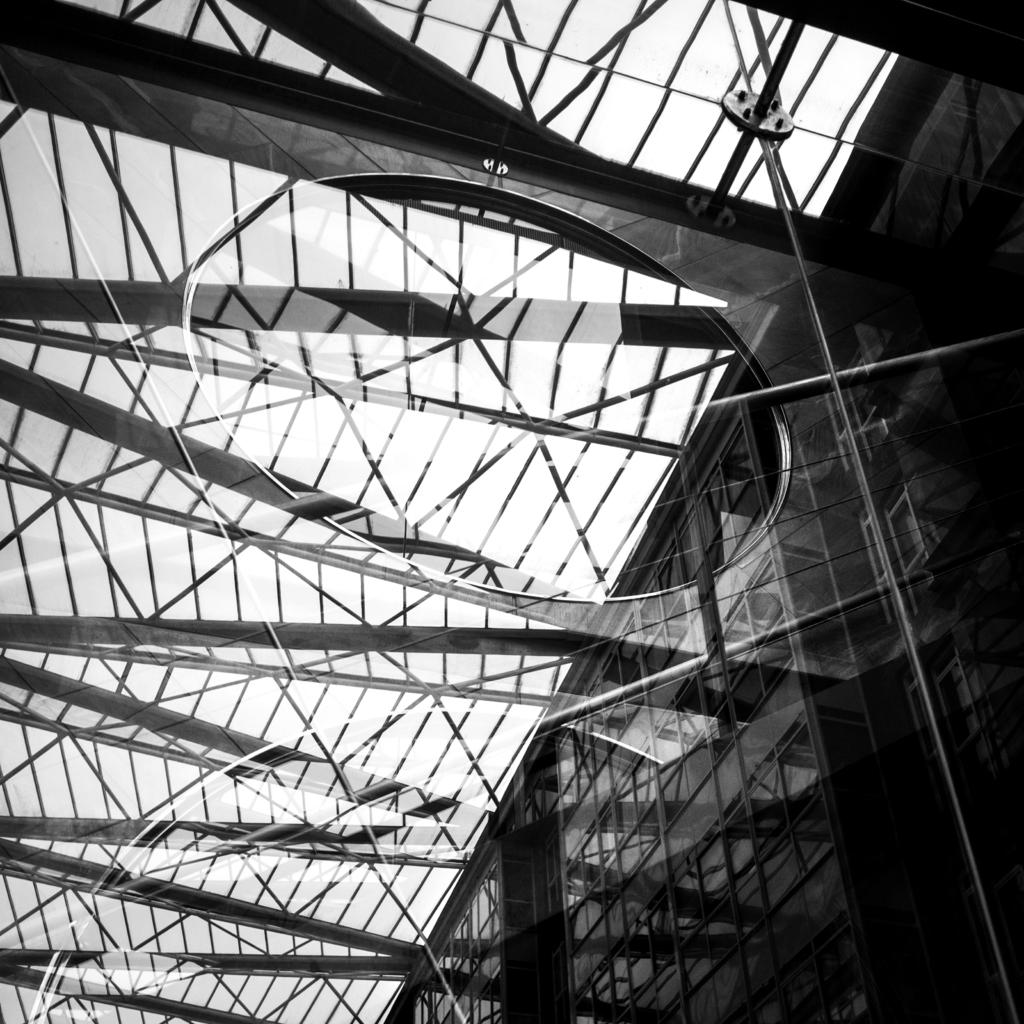What is the color scheme of the image? The image is black and white. What structure can be seen on the right side of the image? There is a building on the right side of the image. What type of material is used for the rods at the top of the image? The rods at the top of the image are made of metal. What is visible at the top of the image? The sky is visible at the top of the image. How does the bridge in the image support the weight of vehicles? There is no bridge present in the image; it only features a building and metal rods. 